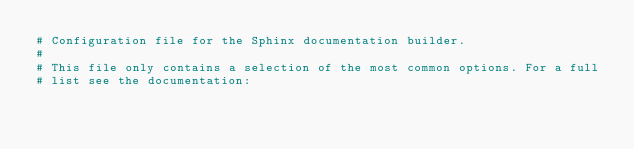Convert code to text. <code><loc_0><loc_0><loc_500><loc_500><_Python_># Configuration file for the Sphinx documentation builder.
#
# This file only contains a selection of the most common options. For a full
# list see the documentation:</code> 